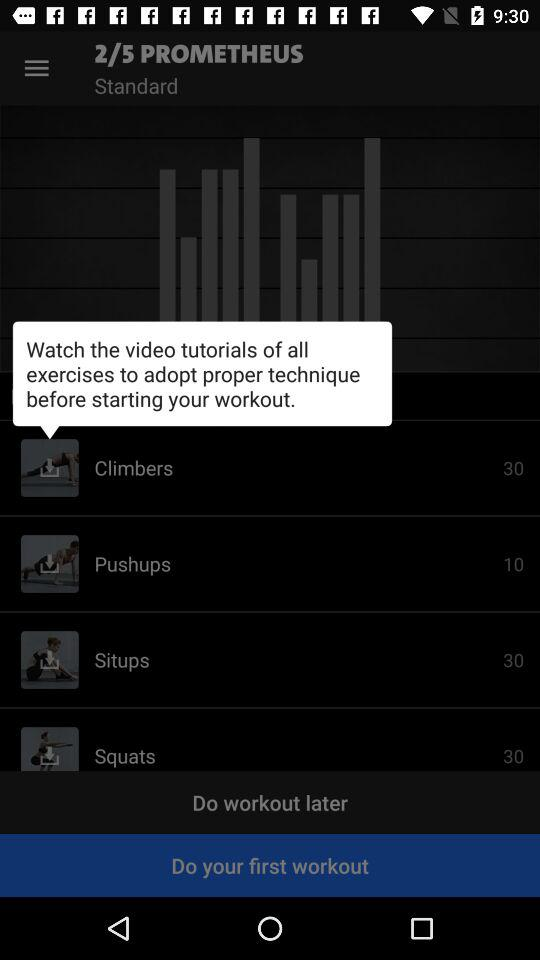What is the total number of situps to be performed? The total number of situps to be performed is 30. 